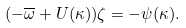Convert formula to latex. <formula><loc_0><loc_0><loc_500><loc_500>( - \overline { \omega } + U ( \kappa ) ) \zeta = - \psi ( \kappa ) .</formula> 